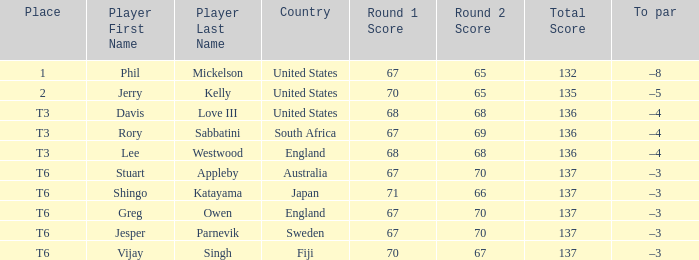Name the place for score of 67-70=137 and stuart appleby T6. 